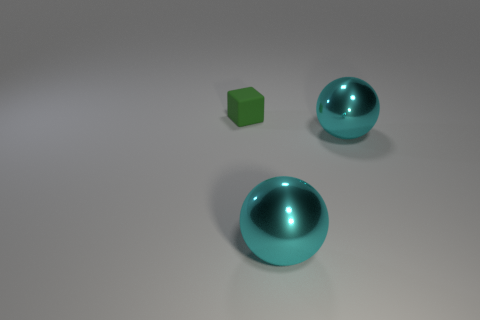Add 1 small objects. How many objects exist? 4 Subtract all blocks. How many objects are left? 2 Subtract all big cylinders. Subtract all large cyan spheres. How many objects are left? 1 Add 2 shiny things. How many shiny things are left? 4 Add 2 shiny things. How many shiny things exist? 4 Subtract 0 purple spheres. How many objects are left? 3 